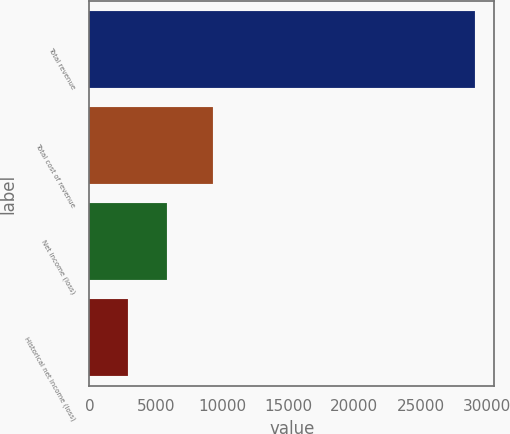Convert chart to OTSL. <chart><loc_0><loc_0><loc_500><loc_500><bar_chart><fcel>Total revenue<fcel>Total cost of revenue<fcel>Net income (loss)<fcel>Historical net income (loss)<nl><fcel>29102<fcel>9293<fcel>5821.55<fcel>2911.49<nl></chart> 